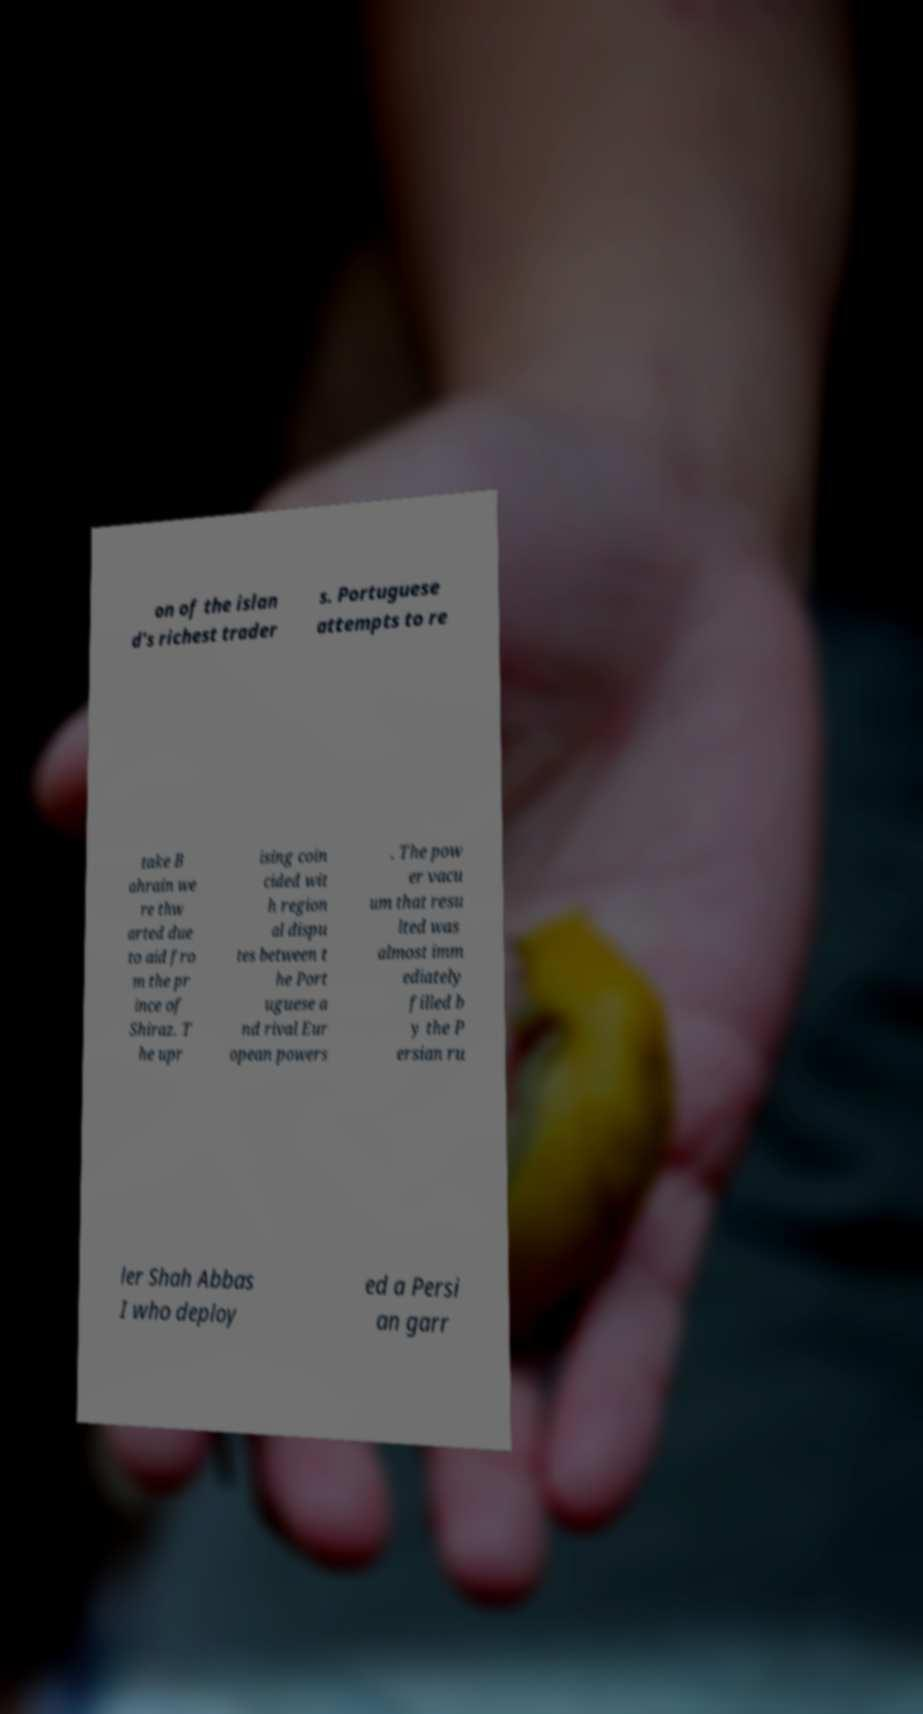I need the written content from this picture converted into text. Can you do that? on of the islan d's richest trader s. Portuguese attempts to re take B ahrain we re thw arted due to aid fro m the pr ince of Shiraz. T he upr ising coin cided wit h region al dispu tes between t he Port uguese a nd rival Eur opean powers . The pow er vacu um that resu lted was almost imm ediately filled b y the P ersian ru ler Shah Abbas I who deploy ed a Persi an garr 